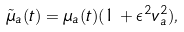<formula> <loc_0><loc_0><loc_500><loc_500>\tilde { \mu } _ { a } ( t ) = \mu _ { a } ( t ) ( 1 + \epsilon ^ { 2 } v _ { a } ^ { 2 } ) ,</formula> 